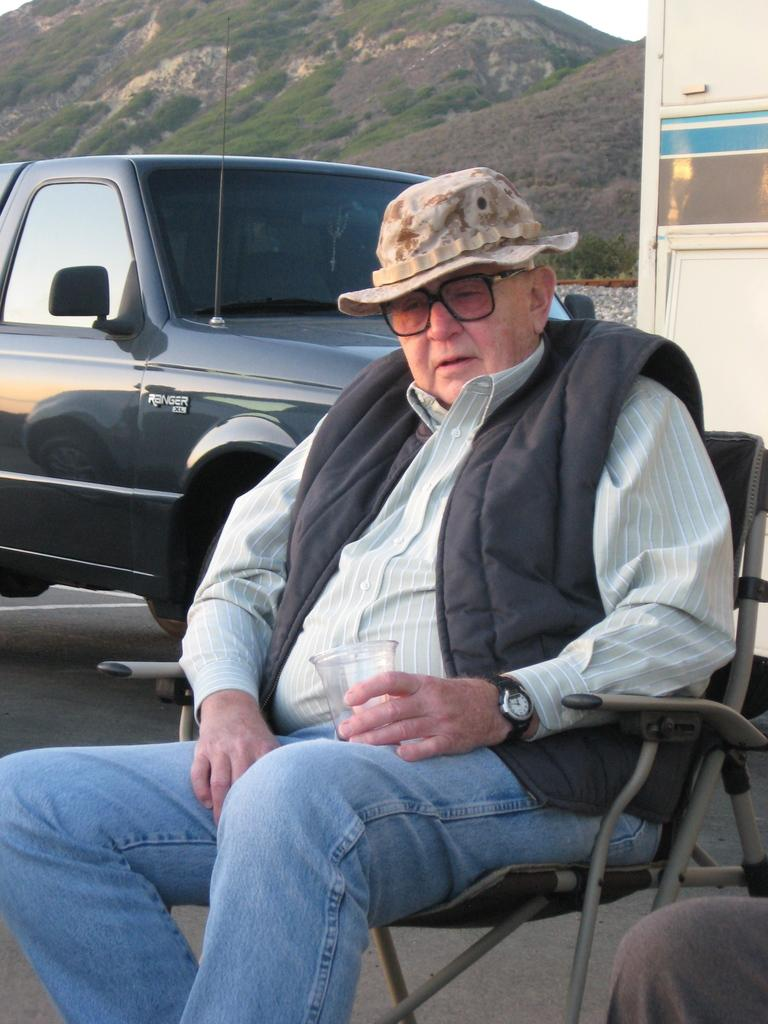What is the man in the image doing? The man is sitting on a chair in the image. What can be seen behind the man? There is a car behind the man. Who is beside the man? There is another person beside the man. What is visible in the distance in the image? There are mountains visible in the background of the image. What type of plantation can be seen in the image? There is no plantation present in the image. 